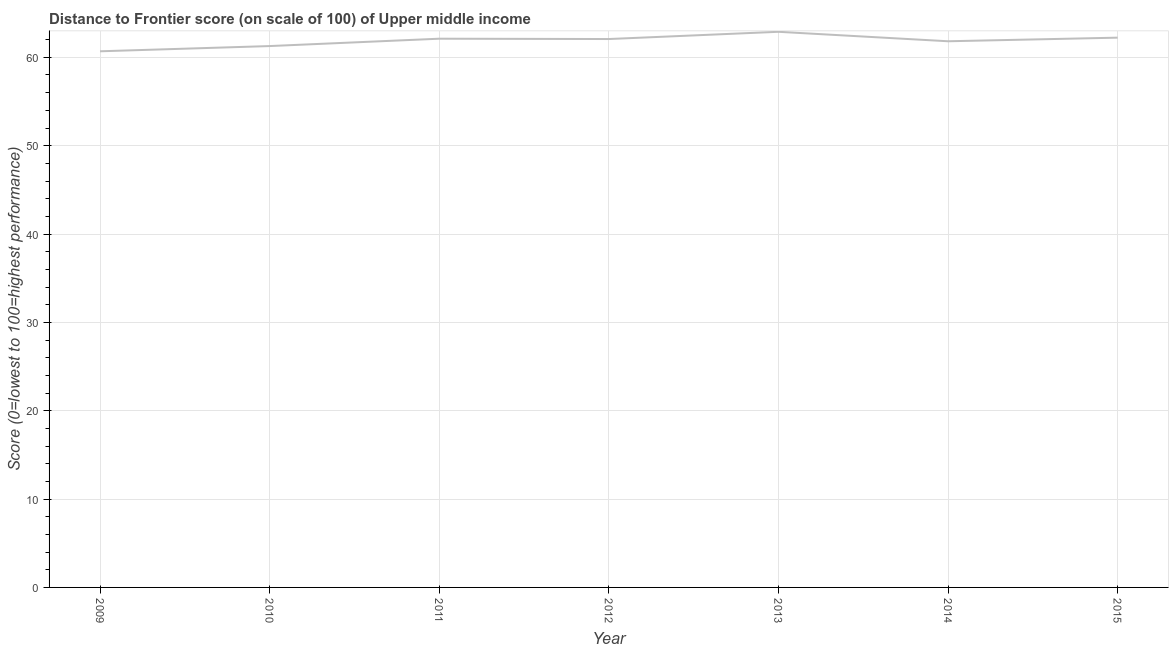What is the distance to frontier score in 2014?
Make the answer very short. 61.82. Across all years, what is the maximum distance to frontier score?
Give a very brief answer. 62.89. Across all years, what is the minimum distance to frontier score?
Provide a succinct answer. 60.68. In which year was the distance to frontier score maximum?
Your answer should be compact. 2013. What is the sum of the distance to frontier score?
Ensure brevity in your answer.  433.07. What is the difference between the distance to frontier score in 2013 and 2015?
Provide a short and direct response. 0.66. What is the average distance to frontier score per year?
Your answer should be very brief. 61.87. What is the median distance to frontier score?
Your response must be concise. 62.07. In how many years, is the distance to frontier score greater than 50 ?
Provide a succinct answer. 7. What is the ratio of the distance to frontier score in 2010 to that in 2011?
Ensure brevity in your answer.  0.99. Is the distance to frontier score in 2009 less than that in 2011?
Ensure brevity in your answer.  Yes. What is the difference between the highest and the second highest distance to frontier score?
Offer a very short reply. 0.66. What is the difference between the highest and the lowest distance to frontier score?
Your answer should be compact. 2.21. Does the graph contain any zero values?
Make the answer very short. No. What is the title of the graph?
Offer a terse response. Distance to Frontier score (on scale of 100) of Upper middle income. What is the label or title of the Y-axis?
Your answer should be very brief. Score (0=lowest to 100=highest performance). What is the Score (0=lowest to 100=highest performance) of 2009?
Give a very brief answer. 60.68. What is the Score (0=lowest to 100=highest performance) of 2010?
Provide a short and direct response. 61.27. What is the Score (0=lowest to 100=highest performance) in 2011?
Provide a succinct answer. 62.11. What is the Score (0=lowest to 100=highest performance) in 2012?
Ensure brevity in your answer.  62.07. What is the Score (0=lowest to 100=highest performance) in 2013?
Provide a short and direct response. 62.89. What is the Score (0=lowest to 100=highest performance) of 2014?
Keep it short and to the point. 61.82. What is the Score (0=lowest to 100=highest performance) in 2015?
Offer a very short reply. 62.23. What is the difference between the Score (0=lowest to 100=highest performance) in 2009 and 2010?
Offer a terse response. -0.59. What is the difference between the Score (0=lowest to 100=highest performance) in 2009 and 2011?
Keep it short and to the point. -1.42. What is the difference between the Score (0=lowest to 100=highest performance) in 2009 and 2012?
Offer a very short reply. -1.39. What is the difference between the Score (0=lowest to 100=highest performance) in 2009 and 2013?
Ensure brevity in your answer.  -2.21. What is the difference between the Score (0=lowest to 100=highest performance) in 2009 and 2014?
Keep it short and to the point. -1.14. What is the difference between the Score (0=lowest to 100=highest performance) in 2009 and 2015?
Make the answer very short. -1.54. What is the difference between the Score (0=lowest to 100=highest performance) in 2010 and 2011?
Provide a short and direct response. -0.83. What is the difference between the Score (0=lowest to 100=highest performance) in 2010 and 2012?
Give a very brief answer. -0.8. What is the difference between the Score (0=lowest to 100=highest performance) in 2010 and 2013?
Offer a terse response. -1.61. What is the difference between the Score (0=lowest to 100=highest performance) in 2010 and 2014?
Give a very brief answer. -0.54. What is the difference between the Score (0=lowest to 100=highest performance) in 2010 and 2015?
Provide a short and direct response. -0.95. What is the difference between the Score (0=lowest to 100=highest performance) in 2011 and 2012?
Your answer should be very brief. 0.04. What is the difference between the Score (0=lowest to 100=highest performance) in 2011 and 2013?
Offer a very short reply. -0.78. What is the difference between the Score (0=lowest to 100=highest performance) in 2011 and 2014?
Make the answer very short. 0.29. What is the difference between the Score (0=lowest to 100=highest performance) in 2011 and 2015?
Make the answer very short. -0.12. What is the difference between the Score (0=lowest to 100=highest performance) in 2012 and 2013?
Your answer should be very brief. -0.82. What is the difference between the Score (0=lowest to 100=highest performance) in 2012 and 2014?
Make the answer very short. 0.25. What is the difference between the Score (0=lowest to 100=highest performance) in 2012 and 2015?
Keep it short and to the point. -0.16. What is the difference between the Score (0=lowest to 100=highest performance) in 2013 and 2014?
Your answer should be very brief. 1.07. What is the difference between the Score (0=lowest to 100=highest performance) in 2013 and 2015?
Your answer should be very brief. 0.66. What is the difference between the Score (0=lowest to 100=highest performance) in 2014 and 2015?
Your response must be concise. -0.41. What is the ratio of the Score (0=lowest to 100=highest performance) in 2009 to that in 2010?
Keep it short and to the point. 0.99. What is the ratio of the Score (0=lowest to 100=highest performance) in 2009 to that in 2015?
Ensure brevity in your answer.  0.97. What is the ratio of the Score (0=lowest to 100=highest performance) in 2010 to that in 2011?
Your response must be concise. 0.99. What is the ratio of the Score (0=lowest to 100=highest performance) in 2010 to that in 2012?
Keep it short and to the point. 0.99. What is the ratio of the Score (0=lowest to 100=highest performance) in 2010 to that in 2013?
Keep it short and to the point. 0.97. What is the ratio of the Score (0=lowest to 100=highest performance) in 2010 to that in 2014?
Offer a terse response. 0.99. What is the ratio of the Score (0=lowest to 100=highest performance) in 2010 to that in 2015?
Ensure brevity in your answer.  0.98. What is the ratio of the Score (0=lowest to 100=highest performance) in 2011 to that in 2014?
Your response must be concise. 1. What is the ratio of the Score (0=lowest to 100=highest performance) in 2011 to that in 2015?
Give a very brief answer. 1. What is the ratio of the Score (0=lowest to 100=highest performance) in 2012 to that in 2013?
Your answer should be very brief. 0.99. What is the ratio of the Score (0=lowest to 100=highest performance) in 2012 to that in 2014?
Your response must be concise. 1. What is the ratio of the Score (0=lowest to 100=highest performance) in 2012 to that in 2015?
Make the answer very short. 1. What is the ratio of the Score (0=lowest to 100=highest performance) in 2013 to that in 2014?
Ensure brevity in your answer.  1.02. 